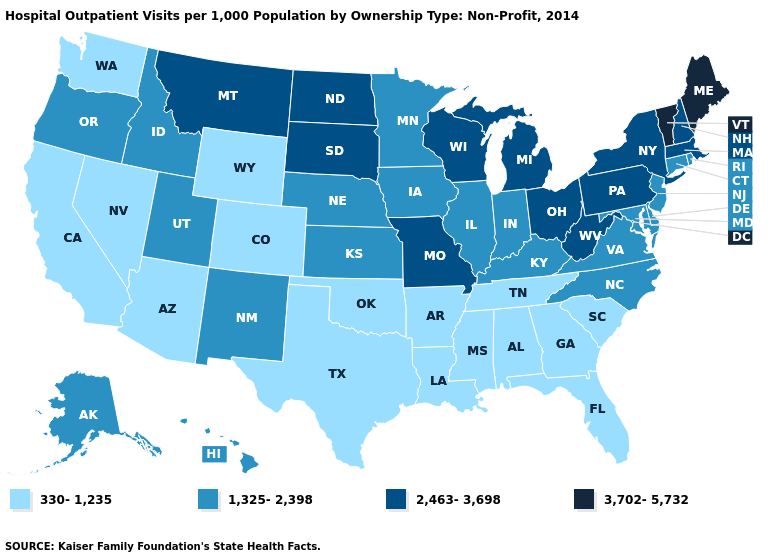Among the states that border Georgia , does North Carolina have the highest value?
Be succinct. Yes. What is the lowest value in the USA?
Short answer required. 330-1,235. What is the lowest value in states that border Wisconsin?
Give a very brief answer. 1,325-2,398. Which states hav the highest value in the MidWest?
Keep it brief. Michigan, Missouri, North Dakota, Ohio, South Dakota, Wisconsin. Name the states that have a value in the range 2,463-3,698?
Quick response, please. Massachusetts, Michigan, Missouri, Montana, New Hampshire, New York, North Dakota, Ohio, Pennsylvania, South Dakota, West Virginia, Wisconsin. Among the states that border Wisconsin , does Minnesota have the highest value?
Give a very brief answer. No. Which states have the lowest value in the USA?
Short answer required. Alabama, Arizona, Arkansas, California, Colorado, Florida, Georgia, Louisiana, Mississippi, Nevada, Oklahoma, South Carolina, Tennessee, Texas, Washington, Wyoming. Does the first symbol in the legend represent the smallest category?
Give a very brief answer. Yes. Among the states that border Nevada , does Arizona have the lowest value?
Answer briefly. Yes. What is the value of Oregon?
Write a very short answer. 1,325-2,398. What is the lowest value in states that border Maryland?
Quick response, please. 1,325-2,398. Does the first symbol in the legend represent the smallest category?
Give a very brief answer. Yes. Does Kansas have the lowest value in the USA?
Concise answer only. No. Does Indiana have the highest value in the USA?
Concise answer only. No. How many symbols are there in the legend?
Write a very short answer. 4. 